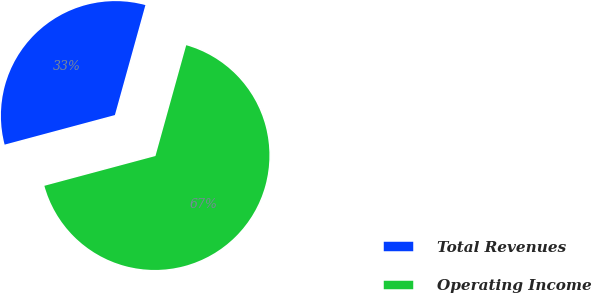<chart> <loc_0><loc_0><loc_500><loc_500><pie_chart><fcel>Total Revenues<fcel>Operating Income<nl><fcel>33.48%<fcel>66.52%<nl></chart> 